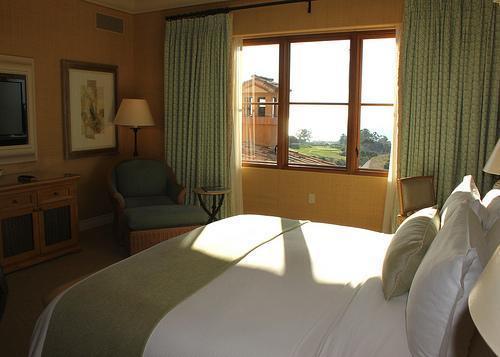How many chairs are in the picture?
Give a very brief answer. 2. 